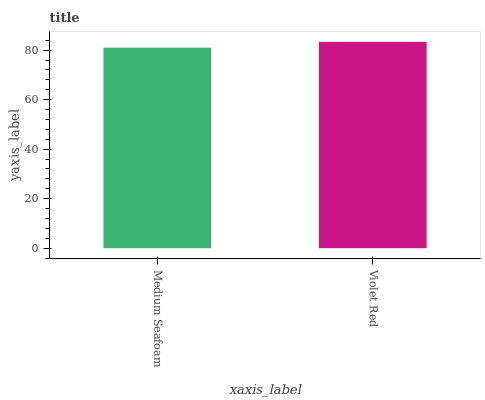Is Medium Seafoam the minimum?
Answer yes or no. Yes. Is Violet Red the maximum?
Answer yes or no. Yes. Is Violet Red the minimum?
Answer yes or no. No. Is Violet Red greater than Medium Seafoam?
Answer yes or no. Yes. Is Medium Seafoam less than Violet Red?
Answer yes or no. Yes. Is Medium Seafoam greater than Violet Red?
Answer yes or no. No. Is Violet Red less than Medium Seafoam?
Answer yes or no. No. Is Violet Red the high median?
Answer yes or no. Yes. Is Medium Seafoam the low median?
Answer yes or no. Yes. Is Medium Seafoam the high median?
Answer yes or no. No. Is Violet Red the low median?
Answer yes or no. No. 